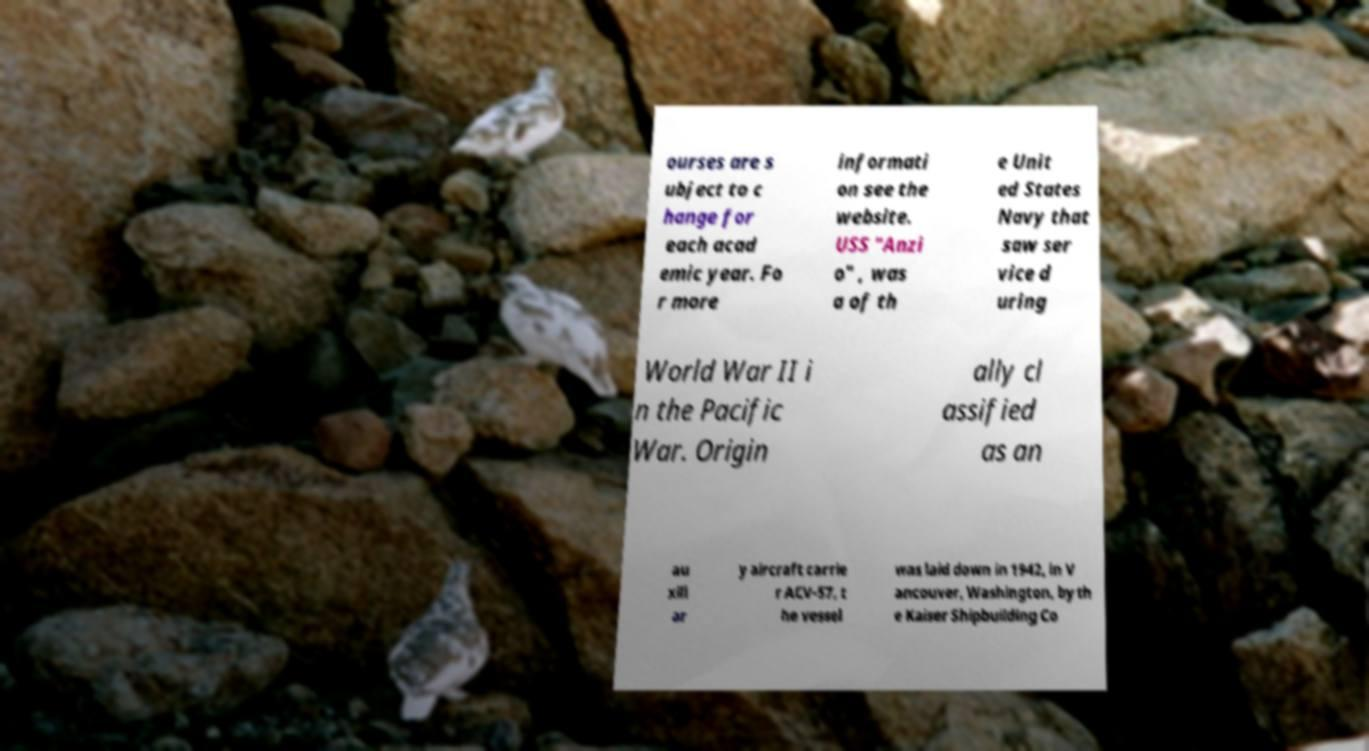Could you extract and type out the text from this image? ourses are s ubject to c hange for each acad emic year. Fo r more informati on see the website. USS "Anzi o" , was a of th e Unit ed States Navy that saw ser vice d uring World War II i n the Pacific War. Origin ally cl assified as an au xili ar y aircraft carrie r ACV-57, t he vessel was laid down in 1942, in V ancouver, Washington, by th e Kaiser Shipbuilding Co 